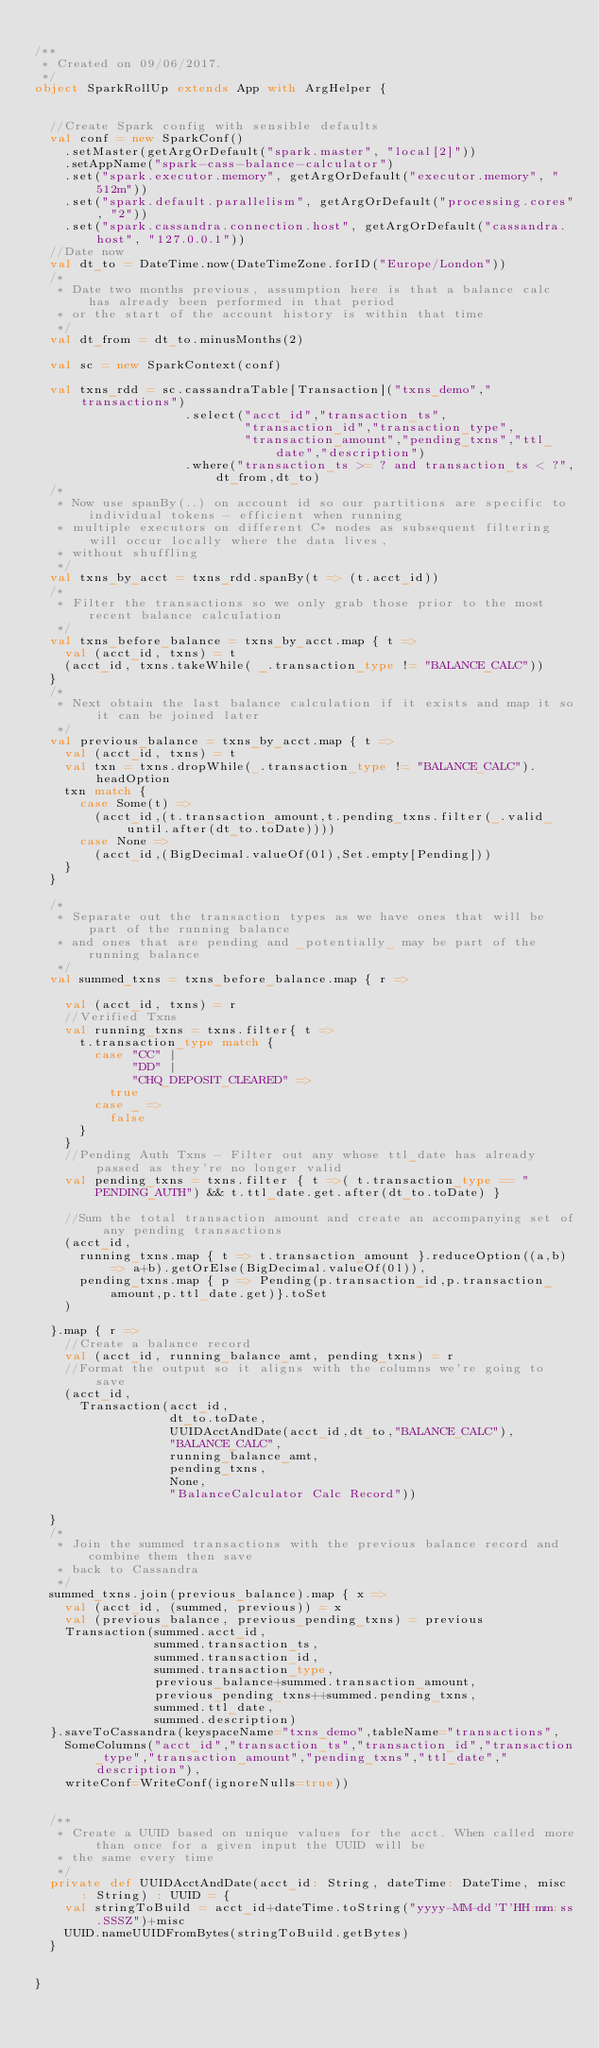Convert code to text. <code><loc_0><loc_0><loc_500><loc_500><_Scala_>
/**
 * Created on 09/06/2017.
 */
object SparkRollUp extends App with ArgHelper {


  //Create Spark config with sensible defaults
  val conf = new SparkConf()
    .setMaster(getArgOrDefault("spark.master", "local[2]"))
    .setAppName("spark-cass-balance-calculator")
    .set("spark.executor.memory", getArgOrDefault("executor.memory", "512m"))
    .set("spark.default.parallelism", getArgOrDefault("processing.cores", "2"))
    .set("spark.cassandra.connection.host", getArgOrDefault("cassandra.host", "127.0.0.1"))
  //Date now
  val dt_to = DateTime.now(DateTimeZone.forID("Europe/London"))
  /*
   * Date two months previous, assumption here is that a balance calc has already been performed in that period
   * or the start of the account history is within that time
   */
  val dt_from = dt_to.minusMonths(2)

  val sc = new SparkContext(conf)

  val txns_rdd = sc.cassandraTable[Transaction]("txns_demo","transactions")
                    .select("acct_id","transaction_ts",
                            "transaction_id","transaction_type",
                            "transaction_amount","pending_txns","ttl_date","description")
                    .where("transaction_ts >= ? and transaction_ts < ?",dt_from,dt_to)
  /*
   * Now use spanBy(..) on account id so our partitions are specific to individual tokens - efficient when running
   * multiple executors on different C* nodes as subsequent filtering will occur locally where the data lives,
   * without shuffling
   */
  val txns_by_acct = txns_rdd.spanBy(t => (t.acct_id))
  /*
   * Filter the transactions so we only grab those prior to the most recent balance calculation
   */
  val txns_before_balance = txns_by_acct.map { t =>
    val (acct_id, txns) = t
    (acct_id, txns.takeWhile( _.transaction_type != "BALANCE_CALC"))
  }
  /*
   * Next obtain the last balance calculation if it exists and map it so it can be joined later
   */
  val previous_balance = txns_by_acct.map { t =>
    val (acct_id, txns) = t
    val txn = txns.dropWhile(_.transaction_type != "BALANCE_CALC").headOption
    txn match {
      case Some(t) =>
        (acct_id,(t.transaction_amount,t.pending_txns.filter(_.valid_until.after(dt_to.toDate))))
      case None =>
        (acct_id,(BigDecimal.valueOf(0l),Set.empty[Pending]))
    }
  }

  /*
   * Separate out the transaction types as we have ones that will be part of the running balance
   * and ones that are pending and _potentially_ may be part of the running balance
   */
  val summed_txns = txns_before_balance.map { r =>

    val (acct_id, txns) = r
    //Verified Txns
    val running_txns = txns.filter{ t =>
      t.transaction_type match {
        case "CC" |
             "DD" |
             "CHQ_DEPOSIT_CLEARED" =>
          true
        case _ =>
          false
      }
    }
    //Pending Auth Txns - Filter out any whose ttl_date has already passed as they're no longer valid
    val pending_txns = txns.filter { t =>( t.transaction_type == "PENDING_AUTH") && t.ttl_date.get.after(dt_to.toDate) }

    //Sum the total transaction amount and create an accompanying set of any pending transactions
    (acct_id,
      running_txns.map { t => t.transaction_amount }.reduceOption((a,b) => a+b).getOrElse(BigDecimal.valueOf(0l)),
      pending_txns.map { p => Pending(p.transaction_id,p.transaction_amount,p.ttl_date.get)}.toSet
    )

  }.map { r =>
    //Create a balance record
    val (acct_id, running_balance_amt, pending_txns) = r
    //Format the output so it aligns with the columns we're going to save
    (acct_id,
      Transaction(acct_id,
                  dt_to.toDate,
                  UUIDAcctAndDate(acct_id,dt_to,"BALANCE_CALC"),
                  "BALANCE_CALC",
                  running_balance_amt,
                  pending_txns,
                  None,
                  "BalanceCalculator Calc Record"))

  }
  /*
   * Join the summed transactions with the previous balance record and combine them then save
   * back to Cassandra
   */
  summed_txns.join(previous_balance).map { x =>
    val (acct_id, (summed, previous)) = x
    val (previous_balance, previous_pending_txns) = previous
    Transaction(summed.acct_id,
                summed.transaction_ts,
                summed.transaction_id,
                summed.transaction_type,
                previous_balance+summed.transaction_amount,
                previous_pending_txns++summed.pending_txns,
                summed.ttl_date,
                summed.description)
  }.saveToCassandra(keyspaceName="txns_demo",tableName="transactions",
    SomeColumns("acct_id","transaction_ts","transaction_id","transaction_type","transaction_amount","pending_txns","ttl_date","description"),
    writeConf=WriteConf(ignoreNulls=true))


  /**
   * Create a UUID based on unique values for the acct. When called more than once for a given input the UUID will be
   * the same every time
   */
  private def UUIDAcctAndDate(acct_id: String, dateTime: DateTime, misc : String) : UUID = {
    val stringToBuild = acct_id+dateTime.toString("yyyy-MM-dd'T'HH:mm:ss.SSSZ")+misc
    UUID.nameUUIDFromBytes(stringToBuild.getBytes)
  }


}
</code> 